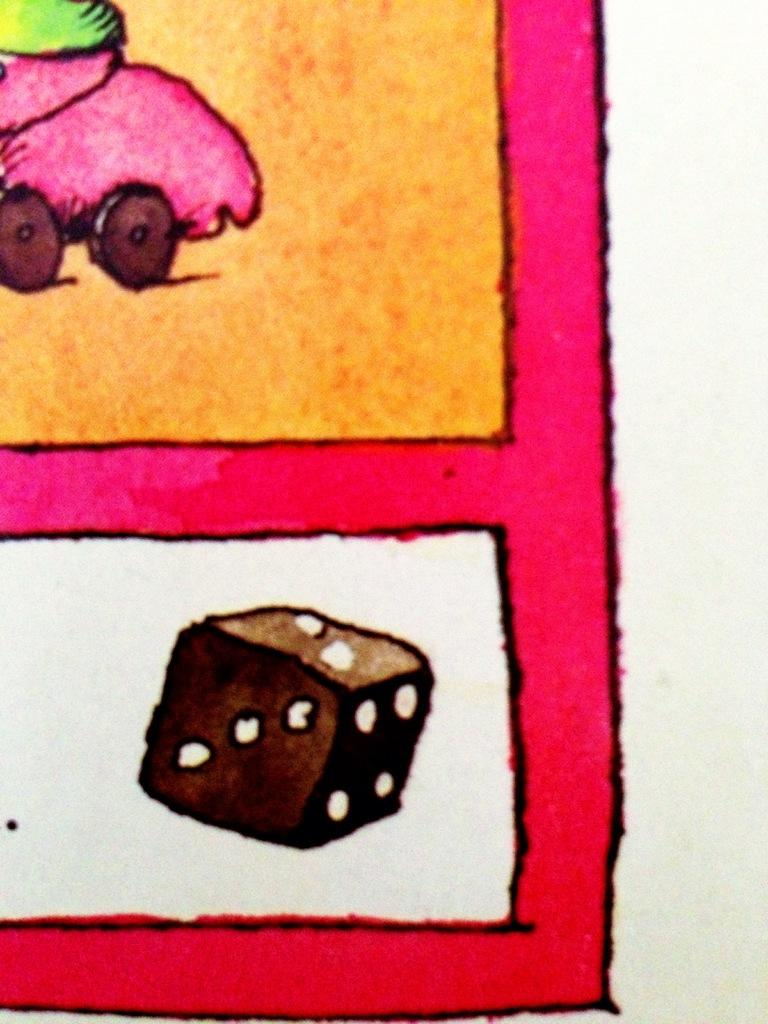What is depicted on the white surface in the image? There is a drawing on a white surface in the image. Where is the toy with wheels located in the image? The toy with wheels is in the left side top corner of the image. What object can be seen at the bottom of the image? There is a dice at the bottom of the image. What type of advertisement is being displayed on the white surface in the image? There is no advertisement present in the image; it features a drawing on a white surface. What type of loss is being depicted in the image? There is no loss depicted in the image; it features a drawing, a toy with wheels, and a dice. 